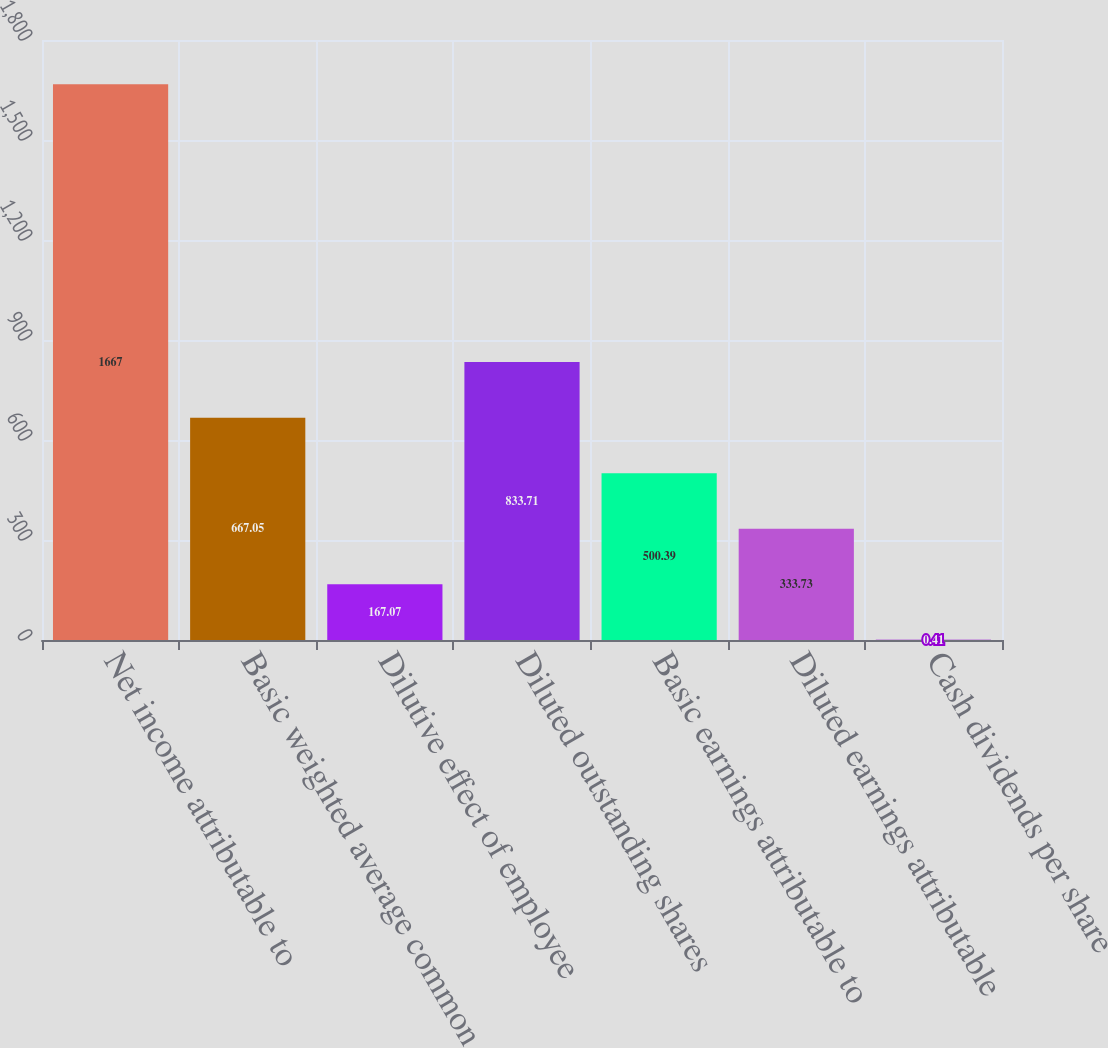Convert chart. <chart><loc_0><loc_0><loc_500><loc_500><bar_chart><fcel>Net income attributable to<fcel>Basicweighted average common<fcel>Dilutive effect of employee<fcel>Diluted outstanding shares<fcel>Basic earnings attributable to<fcel>Diluted earnings attributable<fcel>Cash dividends per share<nl><fcel>1667<fcel>667.05<fcel>167.07<fcel>833.71<fcel>500.39<fcel>333.73<fcel>0.41<nl></chart> 